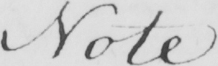Transcribe the text shown in this historical manuscript line. Note 